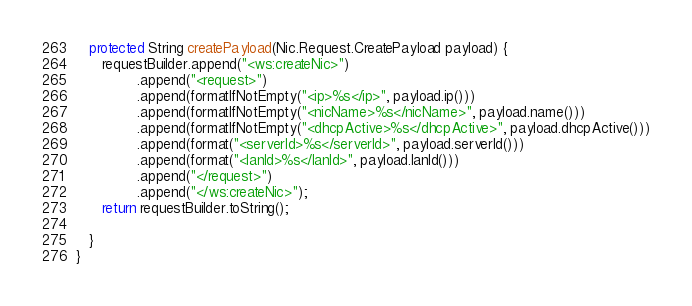<code> <loc_0><loc_0><loc_500><loc_500><_Java_>   protected String createPayload(Nic.Request.CreatePayload payload) {
      requestBuilder.append("<ws:createNic>")
              .append("<request>")
              .append(formatIfNotEmpty("<ip>%s</ip>", payload.ip()))
              .append(formatIfNotEmpty("<nicName>%s</nicName>", payload.name()))
              .append(formatIfNotEmpty("<dhcpActive>%s</dhcpActive>", payload.dhcpActive()))
              .append(format("<serverId>%s</serverId>", payload.serverId()))
              .append(format("<lanId>%s</lanId>", payload.lanId()))
              .append("</request>")
              .append("</ws:createNic>");
      return requestBuilder.toString();

   }
}
</code> 